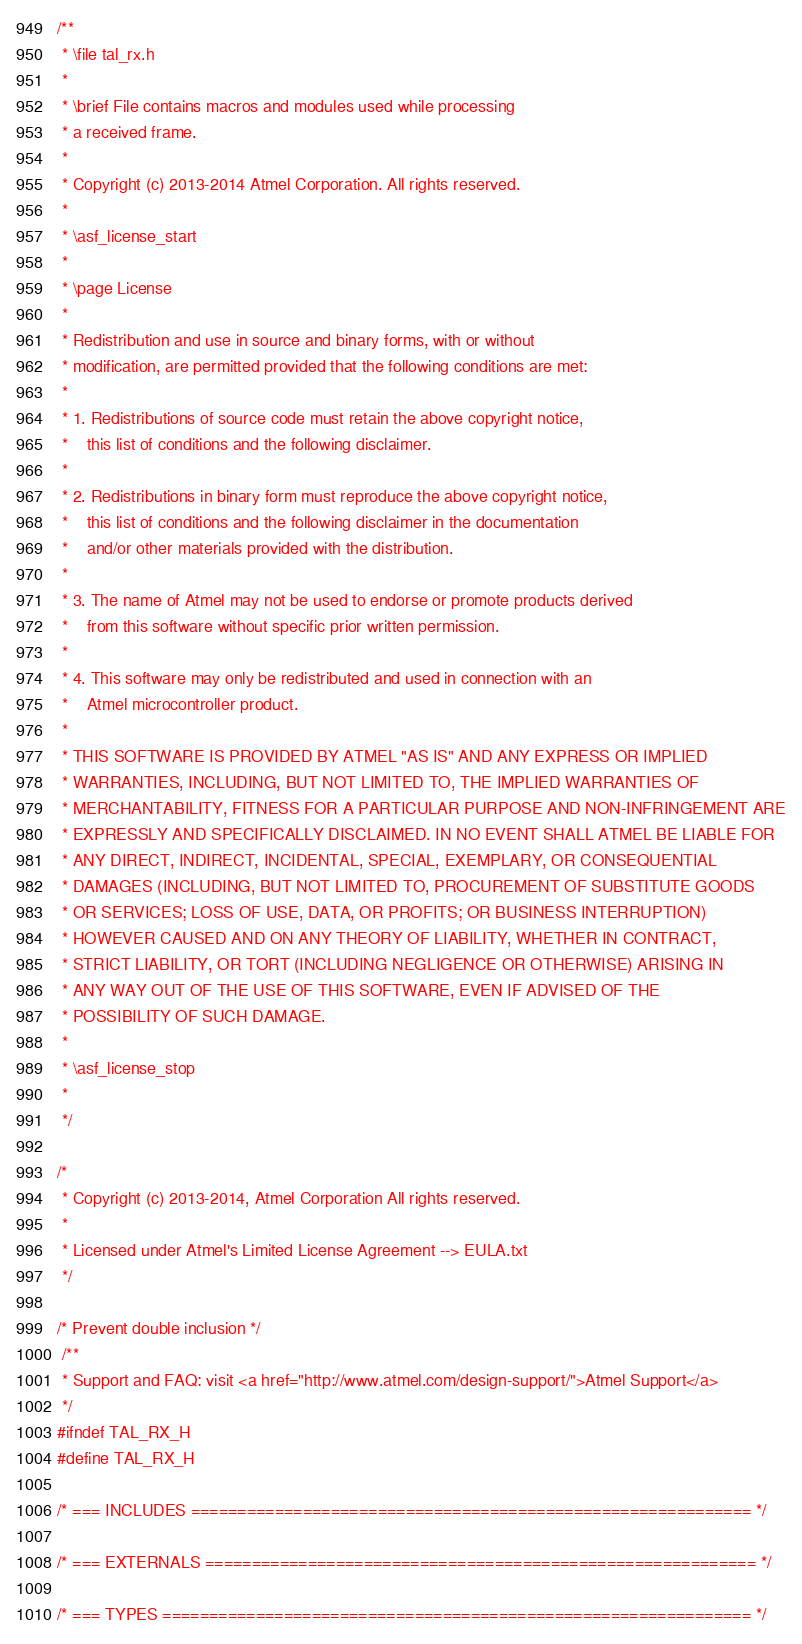Convert code to text. <code><loc_0><loc_0><loc_500><loc_500><_C_>/**
 * \file tal_rx.h
 *
 * \brief File contains macros and modules used while processing
 * a received frame.
 *
 * Copyright (c) 2013-2014 Atmel Corporation. All rights reserved.
 *
 * \asf_license_start
 *
 * \page License
 *
 * Redistribution and use in source and binary forms, with or without
 * modification, are permitted provided that the following conditions are met:
 *
 * 1. Redistributions of source code must retain the above copyright notice,
 *    this list of conditions and the following disclaimer.
 *
 * 2. Redistributions in binary form must reproduce the above copyright notice,
 *    this list of conditions and the following disclaimer in the documentation
 *    and/or other materials provided with the distribution.
 *
 * 3. The name of Atmel may not be used to endorse or promote products derived
 *    from this software without specific prior written permission.
 *
 * 4. This software may only be redistributed and used in connection with an
 *    Atmel microcontroller product.
 *
 * THIS SOFTWARE IS PROVIDED BY ATMEL "AS IS" AND ANY EXPRESS OR IMPLIED
 * WARRANTIES, INCLUDING, BUT NOT LIMITED TO, THE IMPLIED WARRANTIES OF
 * MERCHANTABILITY, FITNESS FOR A PARTICULAR PURPOSE AND NON-INFRINGEMENT ARE
 * EXPRESSLY AND SPECIFICALLY DISCLAIMED. IN NO EVENT SHALL ATMEL BE LIABLE FOR
 * ANY DIRECT, INDIRECT, INCIDENTAL, SPECIAL, EXEMPLARY, OR CONSEQUENTIAL
 * DAMAGES (INCLUDING, BUT NOT LIMITED TO, PROCUREMENT OF SUBSTITUTE GOODS
 * OR SERVICES; LOSS OF USE, DATA, OR PROFITS; OR BUSINESS INTERRUPTION)
 * HOWEVER CAUSED AND ON ANY THEORY OF LIABILITY, WHETHER IN CONTRACT,
 * STRICT LIABILITY, OR TORT (INCLUDING NEGLIGENCE OR OTHERWISE) ARISING IN
 * ANY WAY OUT OF THE USE OF THIS SOFTWARE, EVEN IF ADVISED OF THE
 * POSSIBILITY OF SUCH DAMAGE.
 *
 * \asf_license_stop
 *
 */

/*
 * Copyright (c) 2013-2014, Atmel Corporation All rights reserved.
 *
 * Licensed under Atmel's Limited License Agreement --> EULA.txt
 */

/* Prevent double inclusion */
 /**
 * Support and FAQ: visit <a href="http://www.atmel.com/design-support/">Atmel Support</a>
 */
#ifndef TAL_RX_H
#define TAL_RX_H

/* === INCLUDES ============================================================ */

/* === EXTERNALS =========================================================== */

/* === TYPES =============================================================== */
</code> 